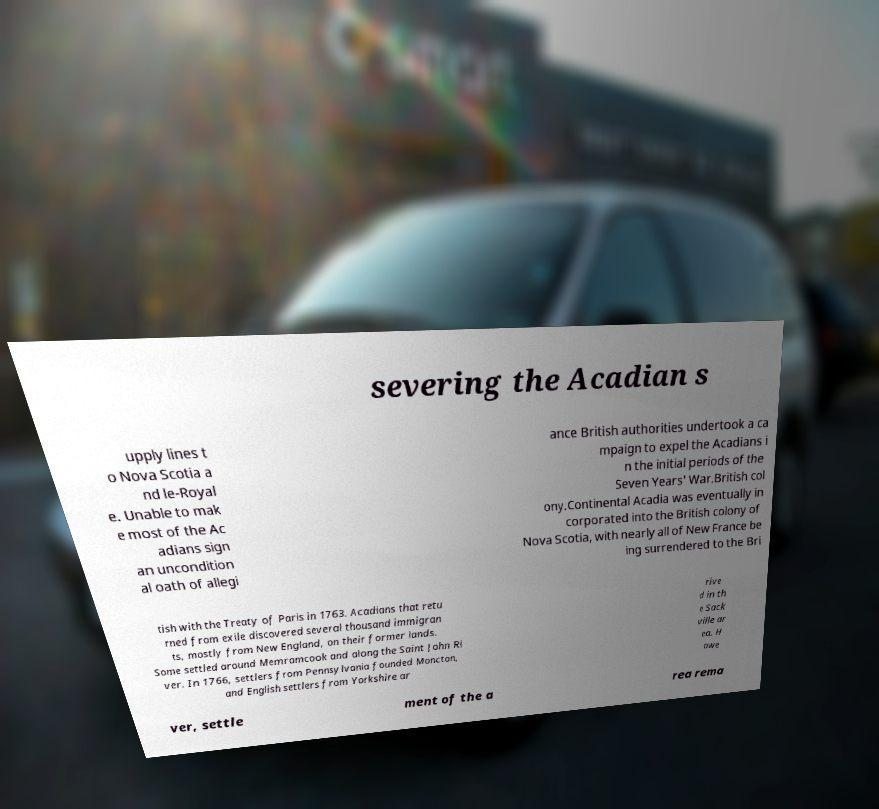Can you read and provide the text displayed in the image?This photo seems to have some interesting text. Can you extract and type it out for me? severing the Acadian s upply lines t o Nova Scotia a nd le-Royal e. Unable to mak e most of the Ac adians sign an uncondition al oath of allegi ance British authorities undertook a ca mpaign to expel the Acadians i n the initial periods of the Seven Years' War.British col ony.Continental Acadia was eventually in corporated into the British colony of Nova Scotia, with nearly all of New France be ing surrendered to the Bri tish with the Treaty of Paris in 1763. Acadians that retu rned from exile discovered several thousand immigran ts, mostly from New England, on their former lands. Some settled around Memramcook and along the Saint John Ri ver. In 1766, settlers from Pennsylvania founded Moncton, and English settlers from Yorkshire ar rive d in th e Sack ville ar ea. H owe ver, settle ment of the a rea rema 